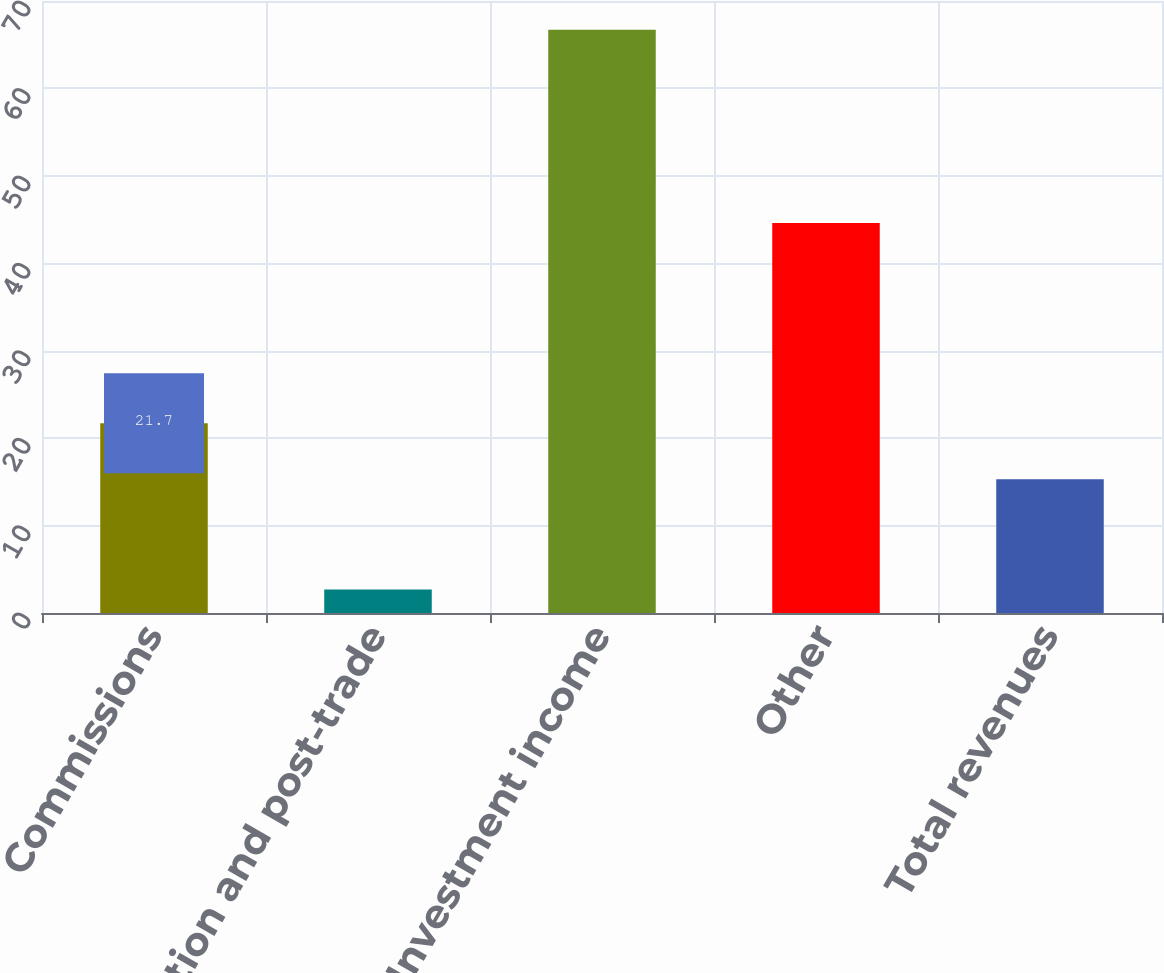Convert chart. <chart><loc_0><loc_0><loc_500><loc_500><bar_chart><fcel>Commissions<fcel>Information and post-trade<fcel>Investment income<fcel>Other<fcel>Total revenues<nl><fcel>21.7<fcel>2.7<fcel>66.7<fcel>44.6<fcel>15.3<nl></chart> 